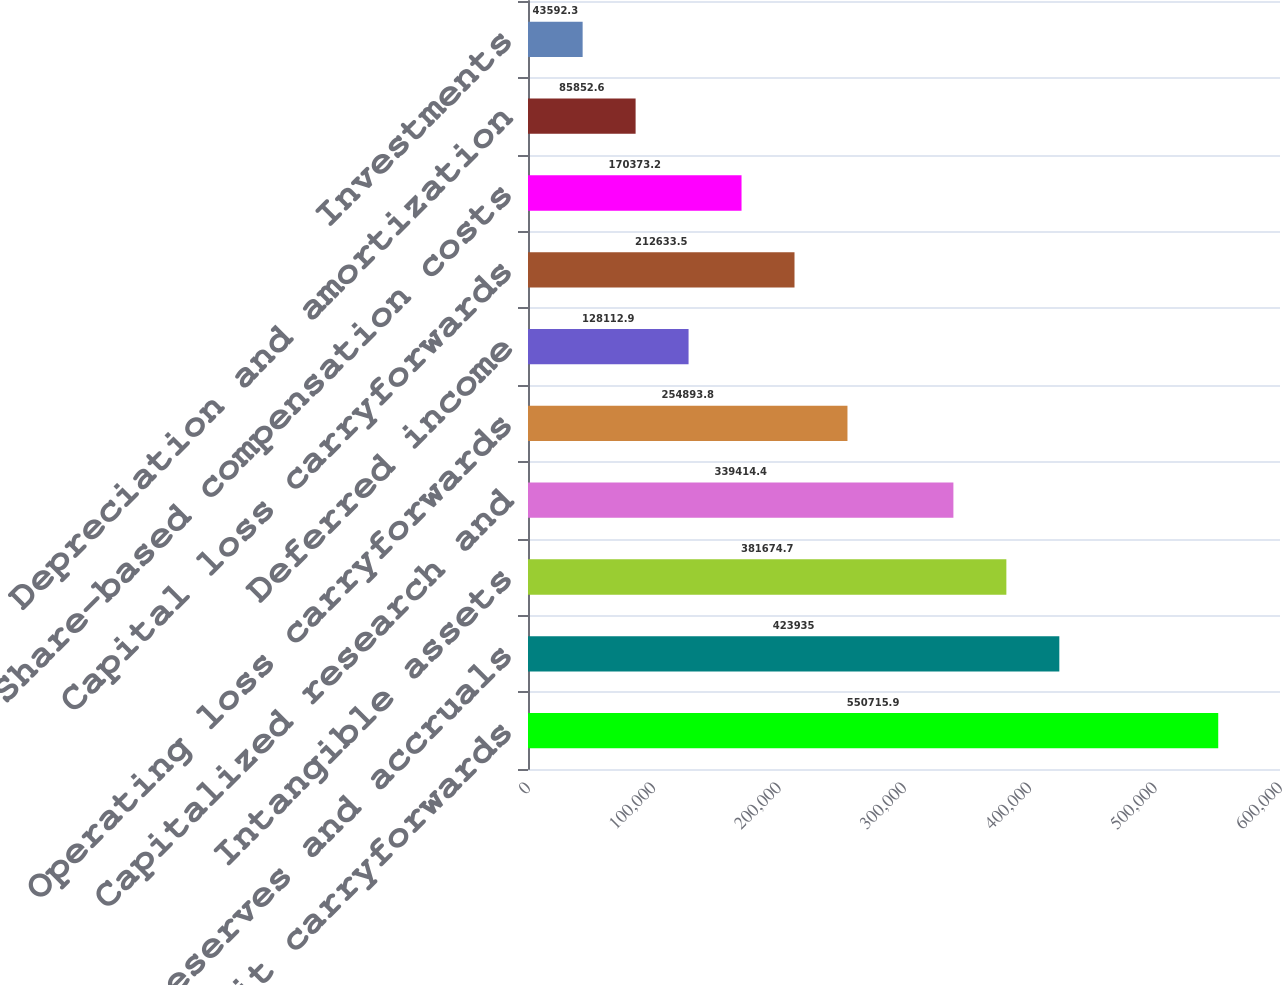<chart> <loc_0><loc_0><loc_500><loc_500><bar_chart><fcel>Tax credit carryforwards<fcel>Reserves and accruals<fcel>Intangible assets<fcel>Capitalized research and<fcel>Operating loss carryforwards<fcel>Deferred income<fcel>Capital loss carryforwards<fcel>Share-based compensation costs<fcel>Depreciation and amortization<fcel>Investments<nl><fcel>550716<fcel>423935<fcel>381675<fcel>339414<fcel>254894<fcel>128113<fcel>212634<fcel>170373<fcel>85852.6<fcel>43592.3<nl></chart> 